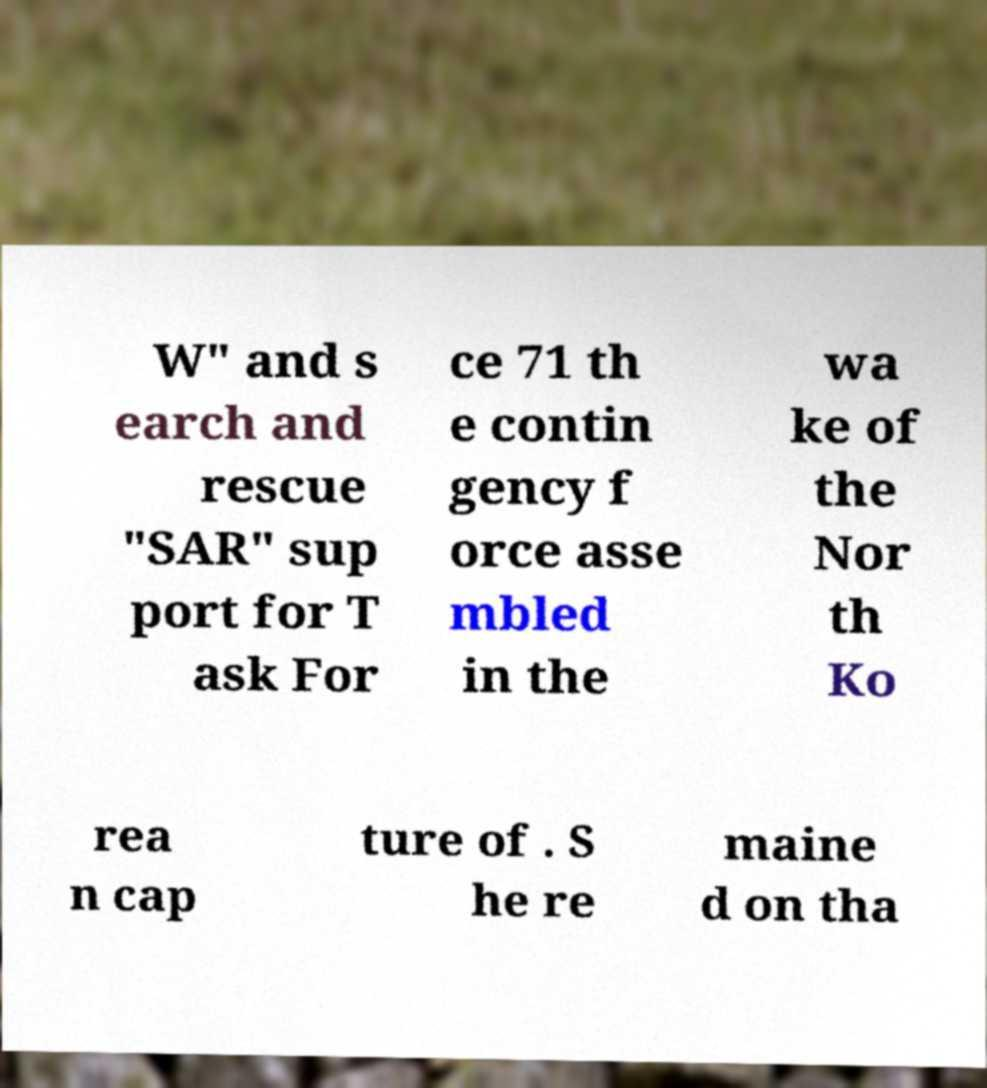There's text embedded in this image that I need extracted. Can you transcribe it verbatim? W" and s earch and rescue "SAR" sup port for T ask For ce 71 th e contin gency f orce asse mbled in the wa ke of the Nor th Ko rea n cap ture of . S he re maine d on tha 